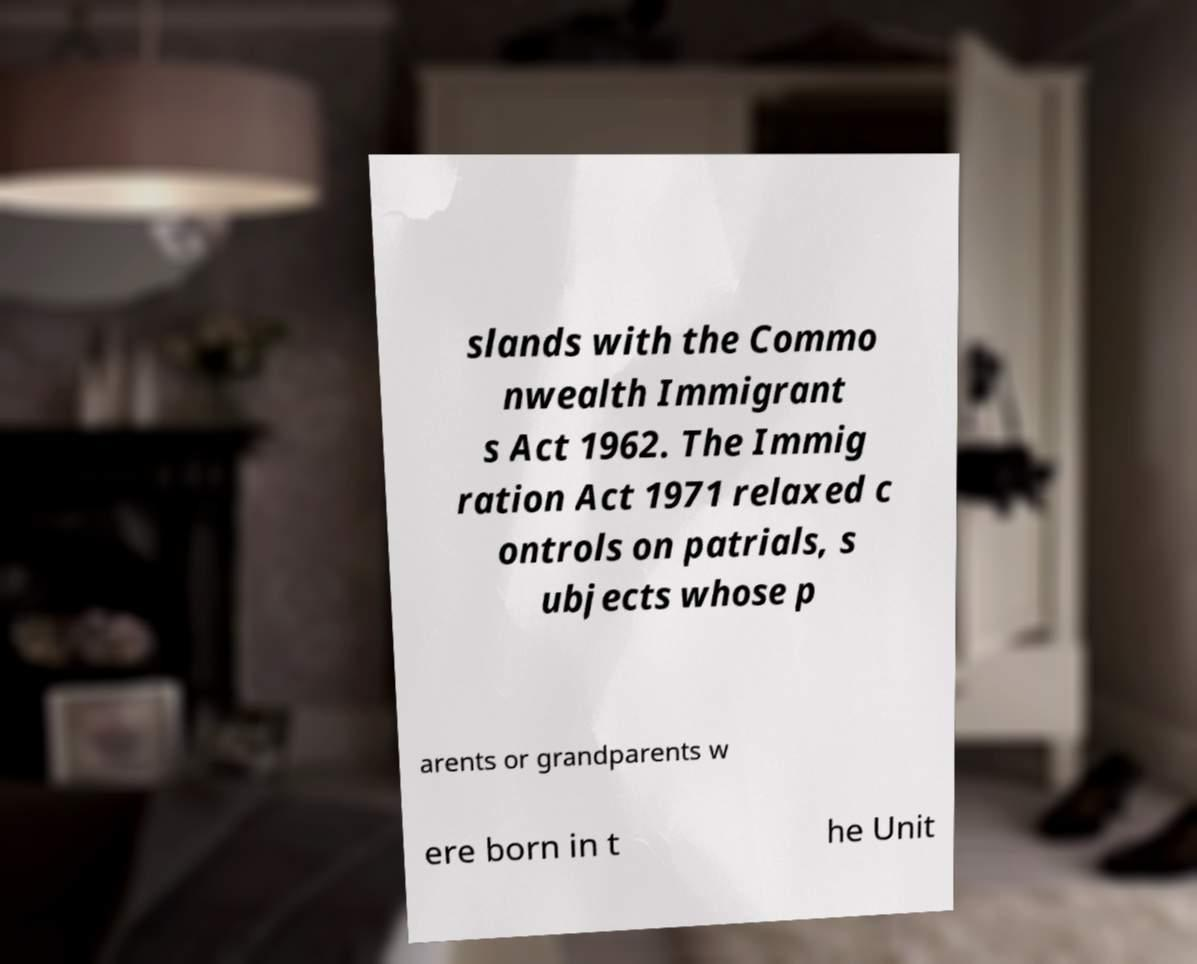Please read and relay the text visible in this image. What does it say? slands with the Commo nwealth Immigrant s Act 1962. The Immig ration Act 1971 relaxed c ontrols on patrials, s ubjects whose p arents or grandparents w ere born in t he Unit 